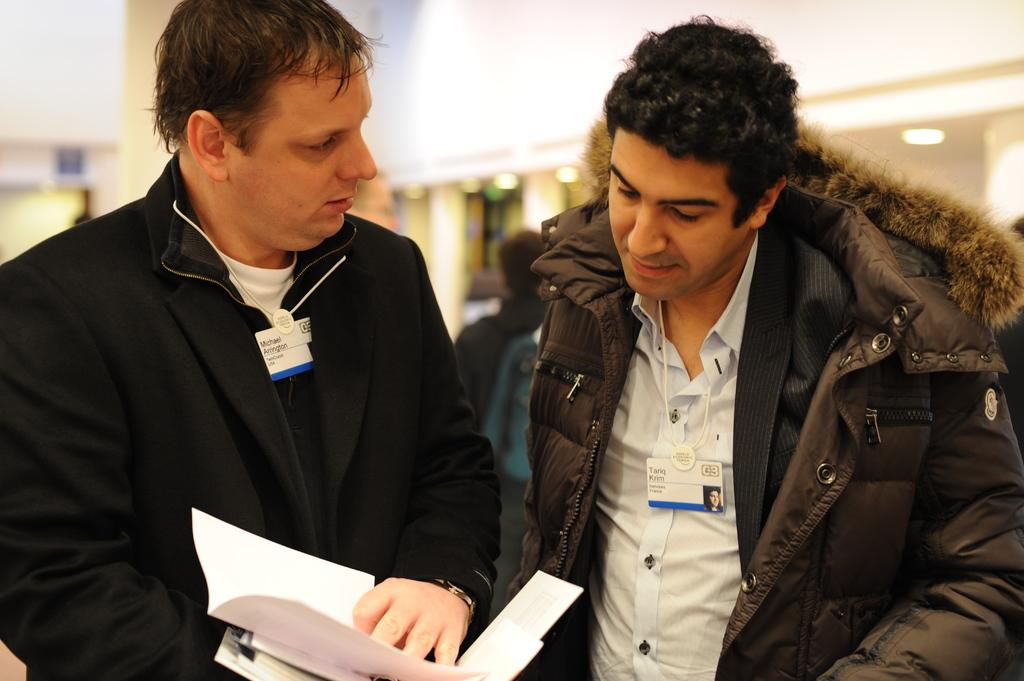How many people are present in the image? There are two people standing in the image. What is the person on the left holding? The person on the left is holding papers. What can be seen on the clothing of both people? Both people are wearing ID cards. Can you describe the background of the image? The background of the image is blurred. What type of nail is being hammered into the person on the right in the image? There is no nail or hammering activity present in the image. What liquid is being poured on the person on the left in the image? There is no liquid being poured on anyone in the image. 